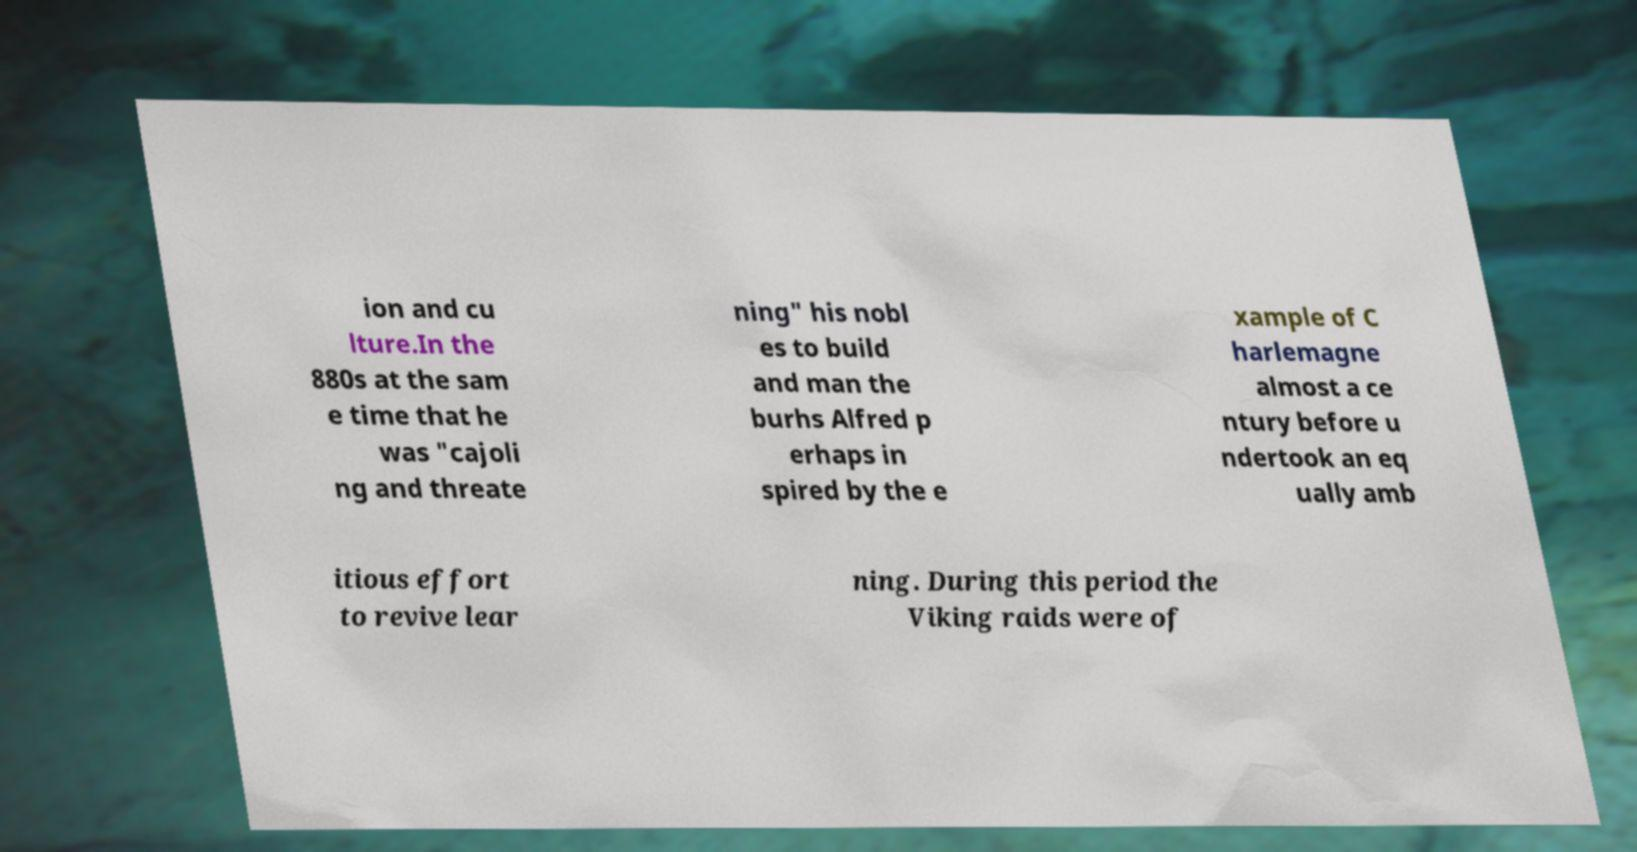Can you read and provide the text displayed in the image?This photo seems to have some interesting text. Can you extract and type it out for me? ion and cu lture.In the 880s at the sam e time that he was "cajoli ng and threate ning" his nobl es to build and man the burhs Alfred p erhaps in spired by the e xample of C harlemagne almost a ce ntury before u ndertook an eq ually amb itious effort to revive lear ning. During this period the Viking raids were of 